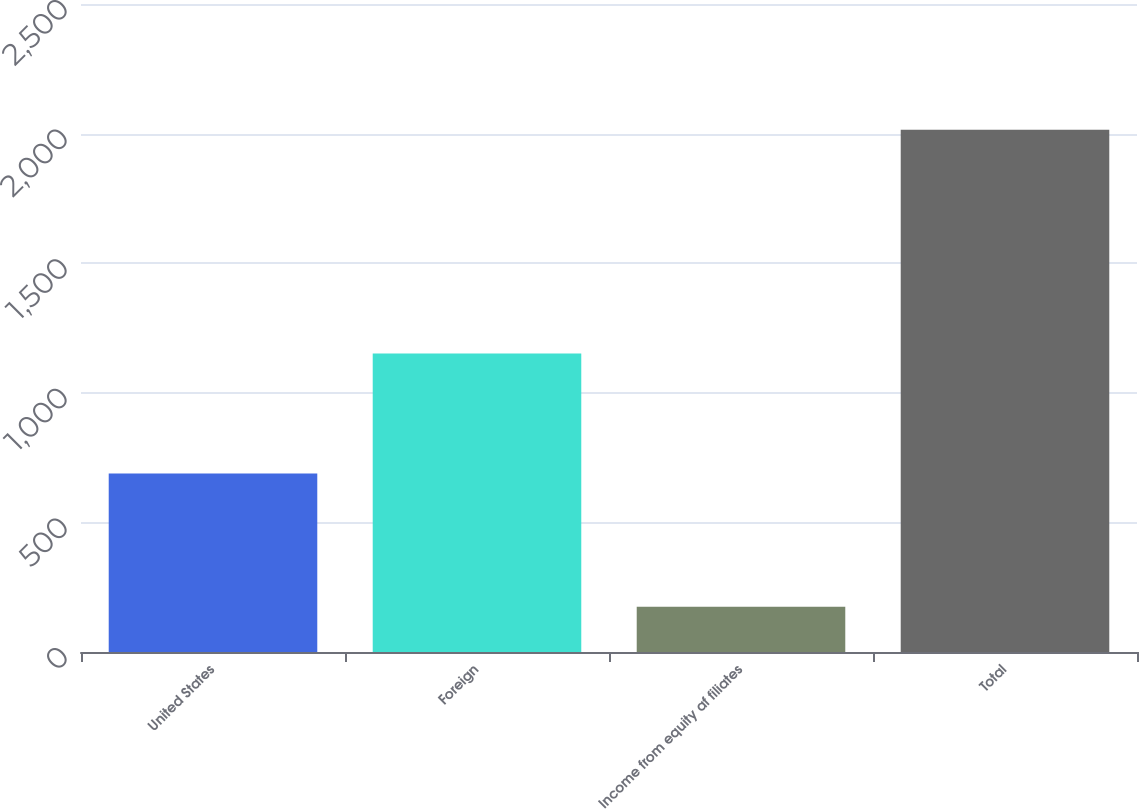Convert chart to OTSL. <chart><loc_0><loc_0><loc_500><loc_500><bar_chart><fcel>United States<fcel>Foreign<fcel>Income from equity af filiates<fcel>Total<nl><fcel>688.5<fcel>1151.7<fcel>174.8<fcel>2015<nl></chart> 